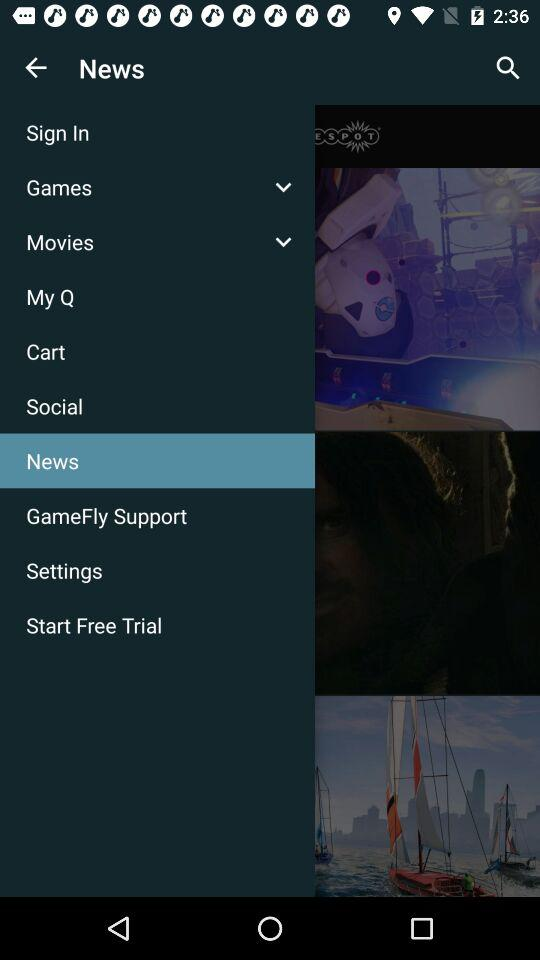Which item has been selected? The selected item is "News". 